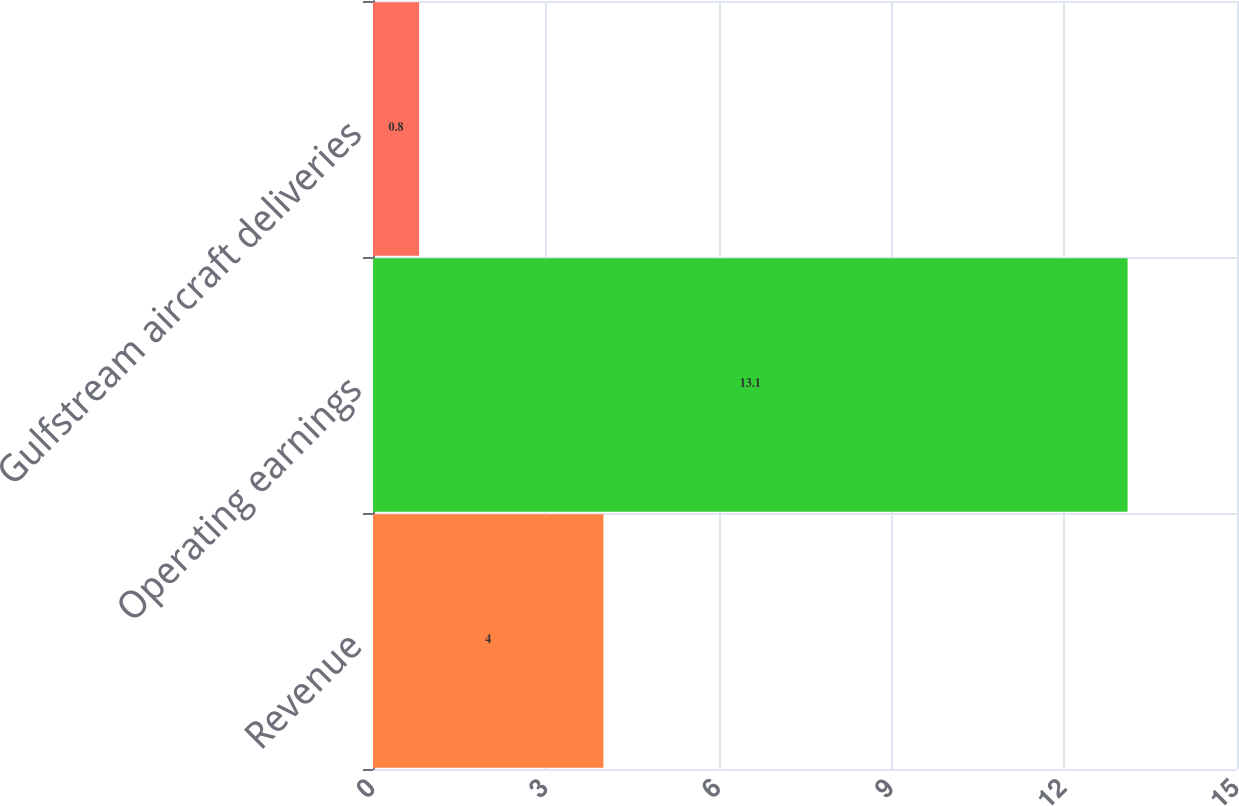Convert chart. <chart><loc_0><loc_0><loc_500><loc_500><bar_chart><fcel>Revenue<fcel>Operating earnings<fcel>Gulfstream aircraft deliveries<nl><fcel>4<fcel>13.1<fcel>0.8<nl></chart> 